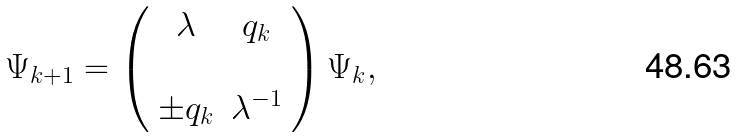Convert formula to latex. <formula><loc_0><loc_0><loc_500><loc_500>\Psi _ { k + 1 } = \left ( \begin{array} { c c } \lambda & q _ { k } \\ \\ \pm q _ { k } & \lambda ^ { - 1 } \end{array} \right ) \Psi _ { k } ,</formula> 